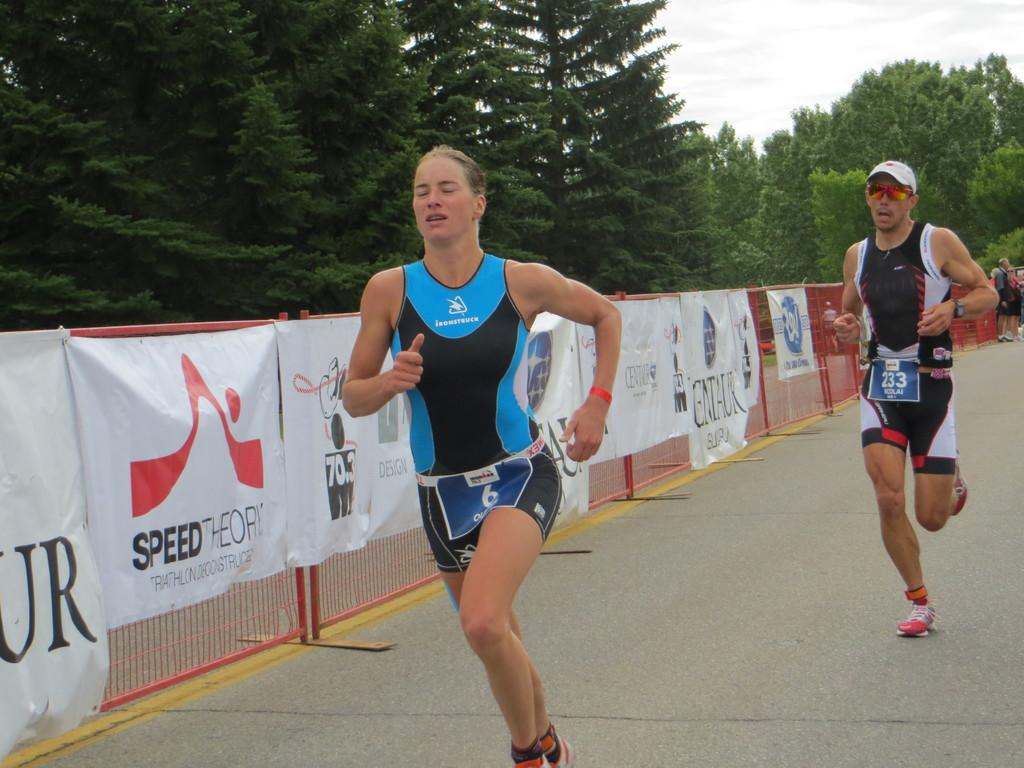Provide a one-sentence caption for the provided image. Runner #6 and runner #233 compete in a race on a road lined with advertisments by Speed Theory and many more. 